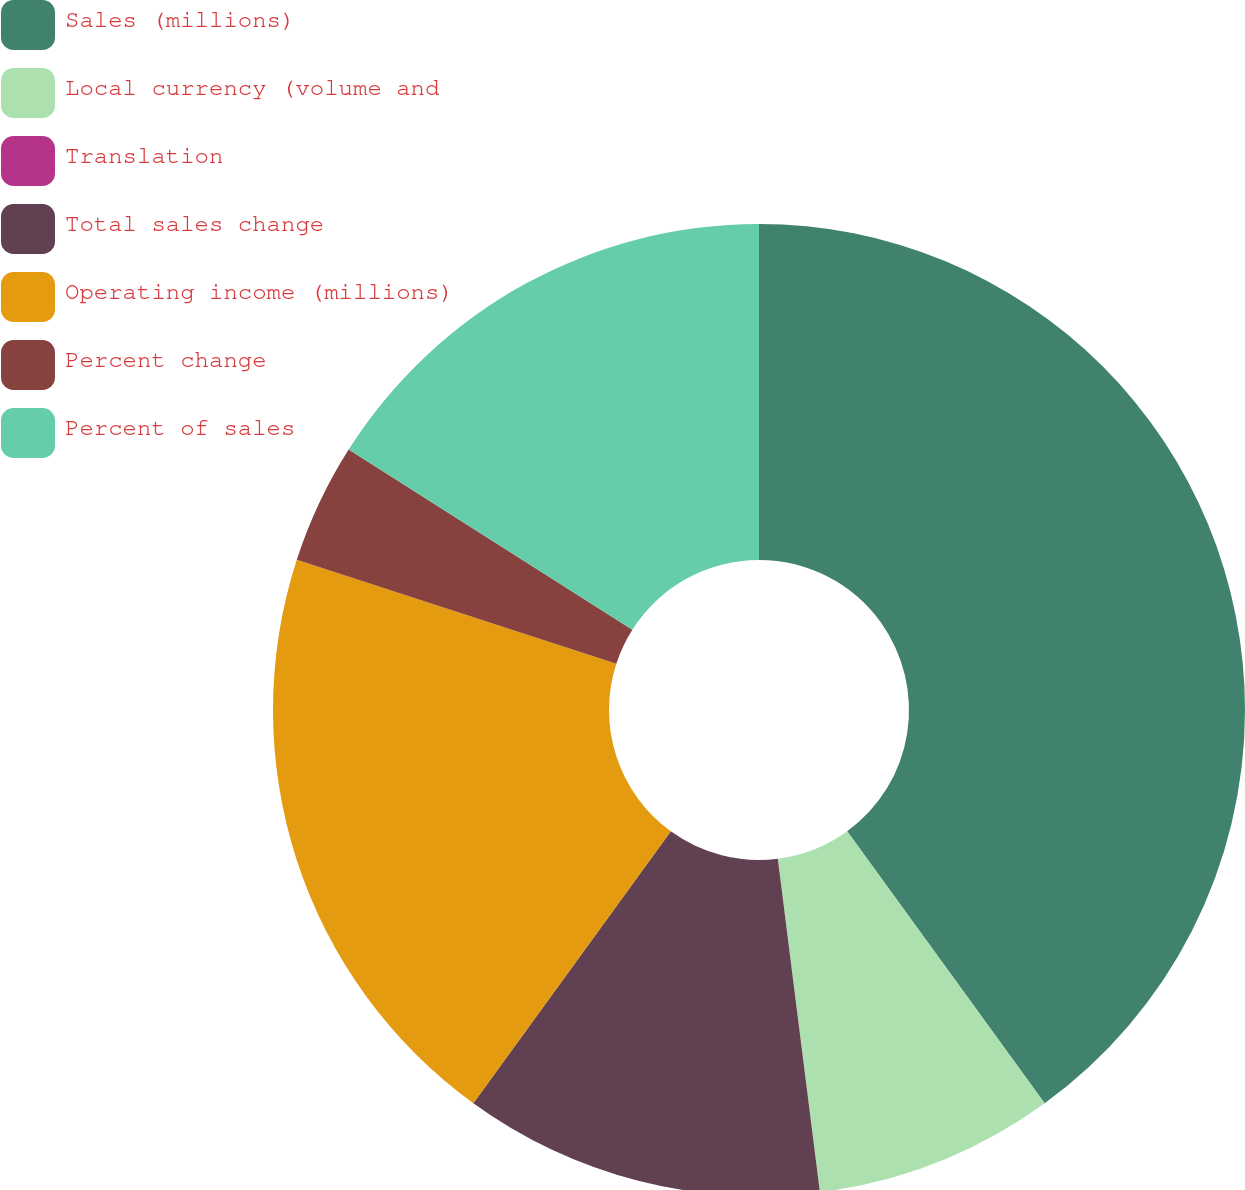Convert chart to OTSL. <chart><loc_0><loc_0><loc_500><loc_500><pie_chart><fcel>Sales (millions)<fcel>Local currency (volume and<fcel>Translation<fcel>Total sales change<fcel>Operating income (millions)<fcel>Percent change<fcel>Percent of sales<nl><fcel>40.0%<fcel>8.0%<fcel>0.0%<fcel>12.0%<fcel>20.0%<fcel>4.0%<fcel>16.0%<nl></chart> 